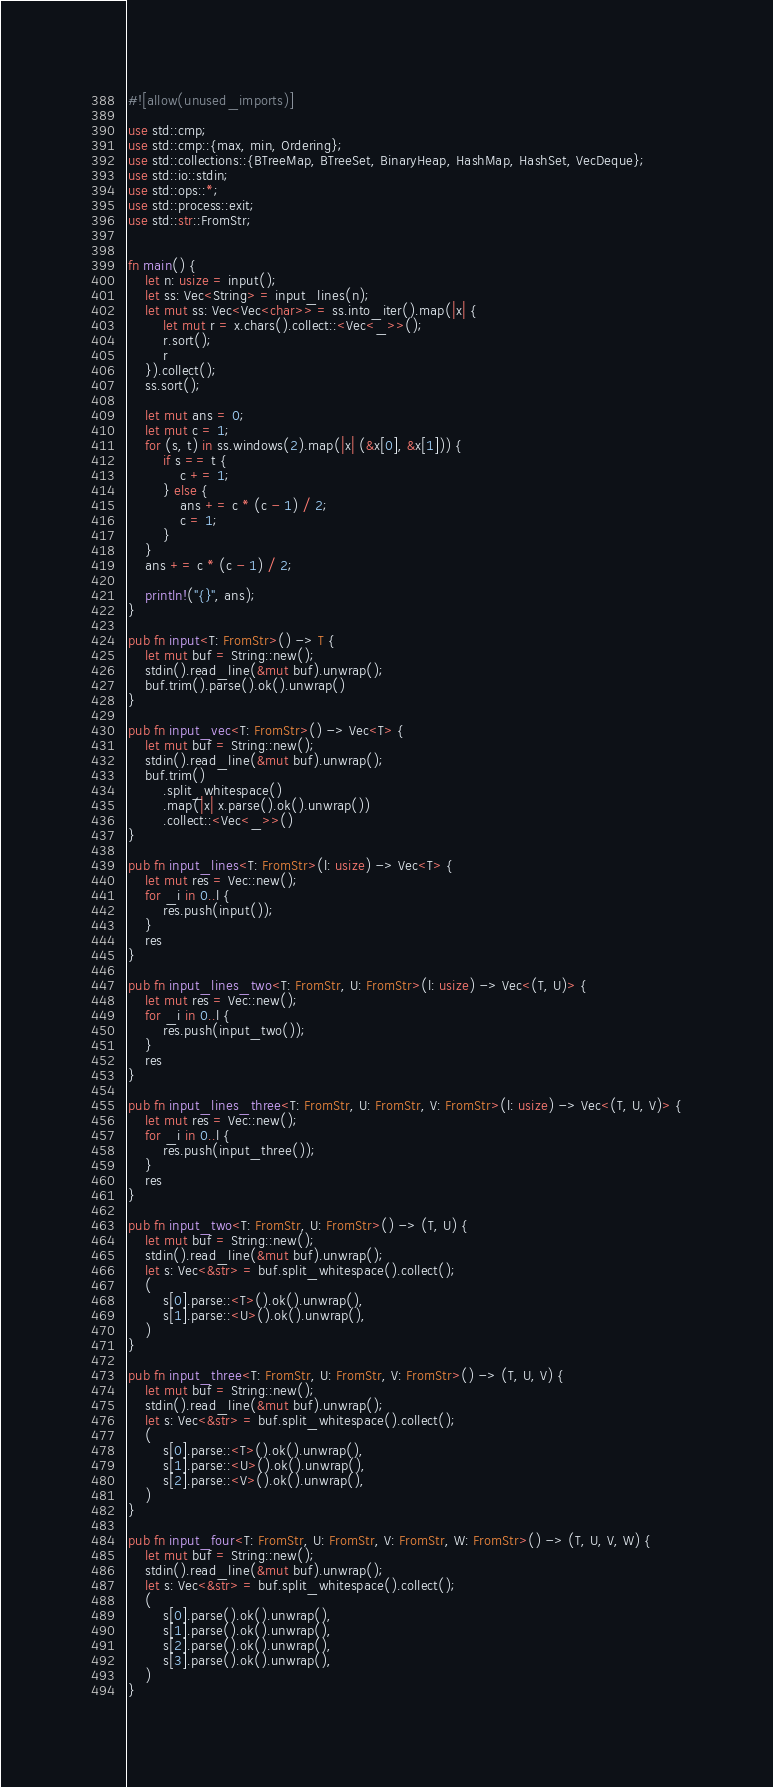<code> <loc_0><loc_0><loc_500><loc_500><_Rust_>#![allow(unused_imports)]

use std::cmp;
use std::cmp::{max, min, Ordering};
use std::collections::{BTreeMap, BTreeSet, BinaryHeap, HashMap, HashSet, VecDeque};
use std::io::stdin;
use std::ops::*;
use std::process::exit;
use std::str::FromStr;


fn main() {
    let n: usize = input();
    let ss: Vec<String> = input_lines(n);
    let mut ss: Vec<Vec<char>> = ss.into_iter().map(|x| {
        let mut r = x.chars().collect::<Vec<_>>();
        r.sort();
        r
    }).collect();
    ss.sort();

    let mut ans = 0;
    let mut c = 1;
    for (s, t) in ss.windows(2).map(|x| (&x[0], &x[1])) {
        if s == t {
            c += 1;
        } else {
            ans += c * (c - 1) / 2;
            c = 1;
        }
    }
    ans += c * (c - 1) / 2;

    println!("{}", ans);
}

pub fn input<T: FromStr>() -> T {
    let mut buf = String::new();
    stdin().read_line(&mut buf).unwrap();
    buf.trim().parse().ok().unwrap()
}

pub fn input_vec<T: FromStr>() -> Vec<T> {
    let mut buf = String::new();
    stdin().read_line(&mut buf).unwrap();
    buf.trim()
        .split_whitespace()
        .map(|x| x.parse().ok().unwrap())
        .collect::<Vec<_>>()
}

pub fn input_lines<T: FromStr>(l: usize) -> Vec<T> {
    let mut res = Vec::new();
    for _i in 0..l {
        res.push(input());
    }
    res
}

pub fn input_lines_two<T: FromStr, U: FromStr>(l: usize) -> Vec<(T, U)> {
    let mut res = Vec::new();
    for _i in 0..l {
        res.push(input_two());
    }
    res
}

pub fn input_lines_three<T: FromStr, U: FromStr, V: FromStr>(l: usize) -> Vec<(T, U, V)> {
    let mut res = Vec::new();
    for _i in 0..l {
        res.push(input_three());
    }
    res
}

pub fn input_two<T: FromStr, U: FromStr>() -> (T, U) {
    let mut buf = String::new();
    stdin().read_line(&mut buf).unwrap();
    let s: Vec<&str> = buf.split_whitespace().collect();
    (
        s[0].parse::<T>().ok().unwrap(),
        s[1].parse::<U>().ok().unwrap(),
    )
}

pub fn input_three<T: FromStr, U: FromStr, V: FromStr>() -> (T, U, V) {
    let mut buf = String::new();
    stdin().read_line(&mut buf).unwrap();
    let s: Vec<&str> = buf.split_whitespace().collect();
    (
        s[0].parse::<T>().ok().unwrap(),
        s[1].parse::<U>().ok().unwrap(),
        s[2].parse::<V>().ok().unwrap(),
    )
}

pub fn input_four<T: FromStr, U: FromStr, V: FromStr, W: FromStr>() -> (T, U, V, W) {
    let mut buf = String::new();
    stdin().read_line(&mut buf).unwrap();
    let s: Vec<&str> = buf.split_whitespace().collect();
    (
        s[0].parse().ok().unwrap(),
        s[1].parse().ok().unwrap(),
        s[2].parse().ok().unwrap(),
        s[3].parse().ok().unwrap(),
    )
}
</code> 